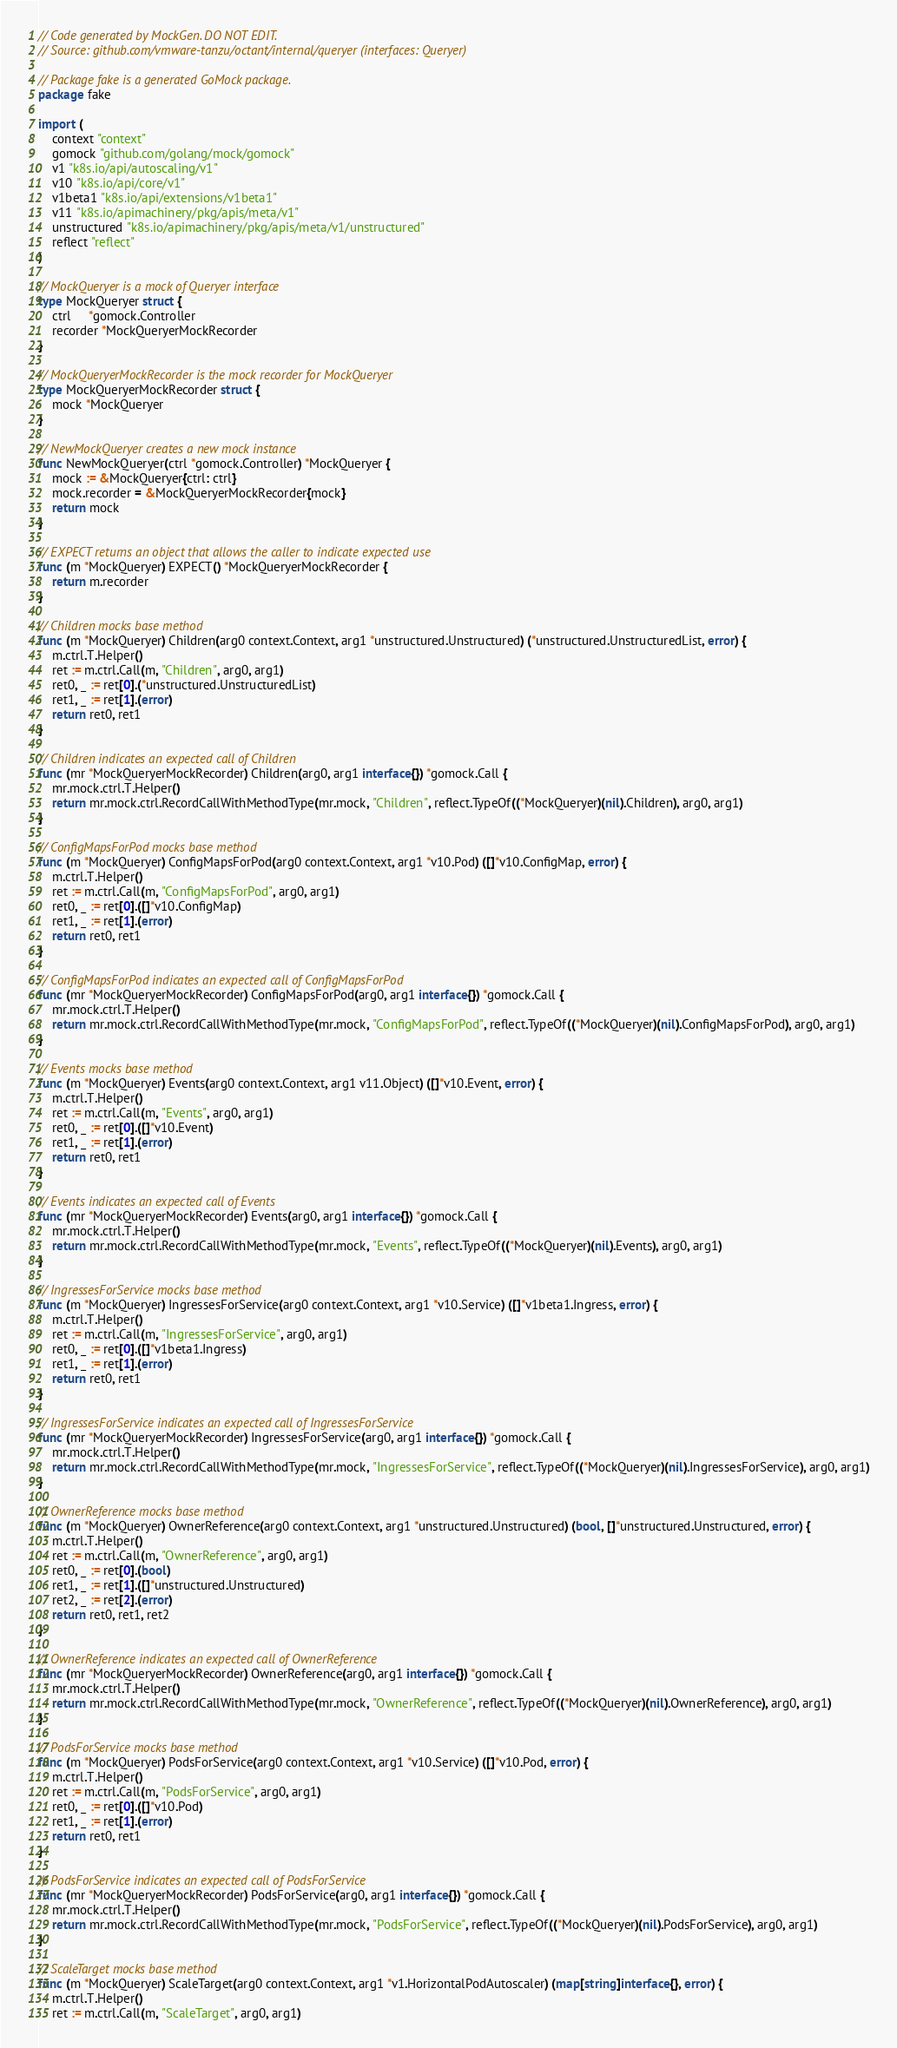<code> <loc_0><loc_0><loc_500><loc_500><_Go_>// Code generated by MockGen. DO NOT EDIT.
// Source: github.com/vmware-tanzu/octant/internal/queryer (interfaces: Queryer)

// Package fake is a generated GoMock package.
package fake

import (
	context "context"
	gomock "github.com/golang/mock/gomock"
	v1 "k8s.io/api/autoscaling/v1"
	v10 "k8s.io/api/core/v1"
	v1beta1 "k8s.io/api/extensions/v1beta1"
	v11 "k8s.io/apimachinery/pkg/apis/meta/v1"
	unstructured "k8s.io/apimachinery/pkg/apis/meta/v1/unstructured"
	reflect "reflect"
)

// MockQueryer is a mock of Queryer interface
type MockQueryer struct {
	ctrl     *gomock.Controller
	recorder *MockQueryerMockRecorder
}

// MockQueryerMockRecorder is the mock recorder for MockQueryer
type MockQueryerMockRecorder struct {
	mock *MockQueryer
}

// NewMockQueryer creates a new mock instance
func NewMockQueryer(ctrl *gomock.Controller) *MockQueryer {
	mock := &MockQueryer{ctrl: ctrl}
	mock.recorder = &MockQueryerMockRecorder{mock}
	return mock
}

// EXPECT returns an object that allows the caller to indicate expected use
func (m *MockQueryer) EXPECT() *MockQueryerMockRecorder {
	return m.recorder
}

// Children mocks base method
func (m *MockQueryer) Children(arg0 context.Context, arg1 *unstructured.Unstructured) (*unstructured.UnstructuredList, error) {
	m.ctrl.T.Helper()
	ret := m.ctrl.Call(m, "Children", arg0, arg1)
	ret0, _ := ret[0].(*unstructured.UnstructuredList)
	ret1, _ := ret[1].(error)
	return ret0, ret1
}

// Children indicates an expected call of Children
func (mr *MockQueryerMockRecorder) Children(arg0, arg1 interface{}) *gomock.Call {
	mr.mock.ctrl.T.Helper()
	return mr.mock.ctrl.RecordCallWithMethodType(mr.mock, "Children", reflect.TypeOf((*MockQueryer)(nil).Children), arg0, arg1)
}

// ConfigMapsForPod mocks base method
func (m *MockQueryer) ConfigMapsForPod(arg0 context.Context, arg1 *v10.Pod) ([]*v10.ConfigMap, error) {
	m.ctrl.T.Helper()
	ret := m.ctrl.Call(m, "ConfigMapsForPod", arg0, arg1)
	ret0, _ := ret[0].([]*v10.ConfigMap)
	ret1, _ := ret[1].(error)
	return ret0, ret1
}

// ConfigMapsForPod indicates an expected call of ConfigMapsForPod
func (mr *MockQueryerMockRecorder) ConfigMapsForPod(arg0, arg1 interface{}) *gomock.Call {
	mr.mock.ctrl.T.Helper()
	return mr.mock.ctrl.RecordCallWithMethodType(mr.mock, "ConfigMapsForPod", reflect.TypeOf((*MockQueryer)(nil).ConfigMapsForPod), arg0, arg1)
}

// Events mocks base method
func (m *MockQueryer) Events(arg0 context.Context, arg1 v11.Object) ([]*v10.Event, error) {
	m.ctrl.T.Helper()
	ret := m.ctrl.Call(m, "Events", arg0, arg1)
	ret0, _ := ret[0].([]*v10.Event)
	ret1, _ := ret[1].(error)
	return ret0, ret1
}

// Events indicates an expected call of Events
func (mr *MockQueryerMockRecorder) Events(arg0, arg1 interface{}) *gomock.Call {
	mr.mock.ctrl.T.Helper()
	return mr.mock.ctrl.RecordCallWithMethodType(mr.mock, "Events", reflect.TypeOf((*MockQueryer)(nil).Events), arg0, arg1)
}

// IngressesForService mocks base method
func (m *MockQueryer) IngressesForService(arg0 context.Context, arg1 *v10.Service) ([]*v1beta1.Ingress, error) {
	m.ctrl.T.Helper()
	ret := m.ctrl.Call(m, "IngressesForService", arg0, arg1)
	ret0, _ := ret[0].([]*v1beta1.Ingress)
	ret1, _ := ret[1].(error)
	return ret0, ret1
}

// IngressesForService indicates an expected call of IngressesForService
func (mr *MockQueryerMockRecorder) IngressesForService(arg0, arg1 interface{}) *gomock.Call {
	mr.mock.ctrl.T.Helper()
	return mr.mock.ctrl.RecordCallWithMethodType(mr.mock, "IngressesForService", reflect.TypeOf((*MockQueryer)(nil).IngressesForService), arg0, arg1)
}

// OwnerReference mocks base method
func (m *MockQueryer) OwnerReference(arg0 context.Context, arg1 *unstructured.Unstructured) (bool, []*unstructured.Unstructured, error) {
	m.ctrl.T.Helper()
	ret := m.ctrl.Call(m, "OwnerReference", arg0, arg1)
	ret0, _ := ret[0].(bool)
	ret1, _ := ret[1].([]*unstructured.Unstructured)
	ret2, _ := ret[2].(error)
	return ret0, ret1, ret2
}

// OwnerReference indicates an expected call of OwnerReference
func (mr *MockQueryerMockRecorder) OwnerReference(arg0, arg1 interface{}) *gomock.Call {
	mr.mock.ctrl.T.Helper()
	return mr.mock.ctrl.RecordCallWithMethodType(mr.mock, "OwnerReference", reflect.TypeOf((*MockQueryer)(nil).OwnerReference), arg0, arg1)
}

// PodsForService mocks base method
func (m *MockQueryer) PodsForService(arg0 context.Context, arg1 *v10.Service) ([]*v10.Pod, error) {
	m.ctrl.T.Helper()
	ret := m.ctrl.Call(m, "PodsForService", arg0, arg1)
	ret0, _ := ret[0].([]*v10.Pod)
	ret1, _ := ret[1].(error)
	return ret0, ret1
}

// PodsForService indicates an expected call of PodsForService
func (mr *MockQueryerMockRecorder) PodsForService(arg0, arg1 interface{}) *gomock.Call {
	mr.mock.ctrl.T.Helper()
	return mr.mock.ctrl.RecordCallWithMethodType(mr.mock, "PodsForService", reflect.TypeOf((*MockQueryer)(nil).PodsForService), arg0, arg1)
}

// ScaleTarget mocks base method
func (m *MockQueryer) ScaleTarget(arg0 context.Context, arg1 *v1.HorizontalPodAutoscaler) (map[string]interface{}, error) {
	m.ctrl.T.Helper()
	ret := m.ctrl.Call(m, "ScaleTarget", arg0, arg1)</code> 